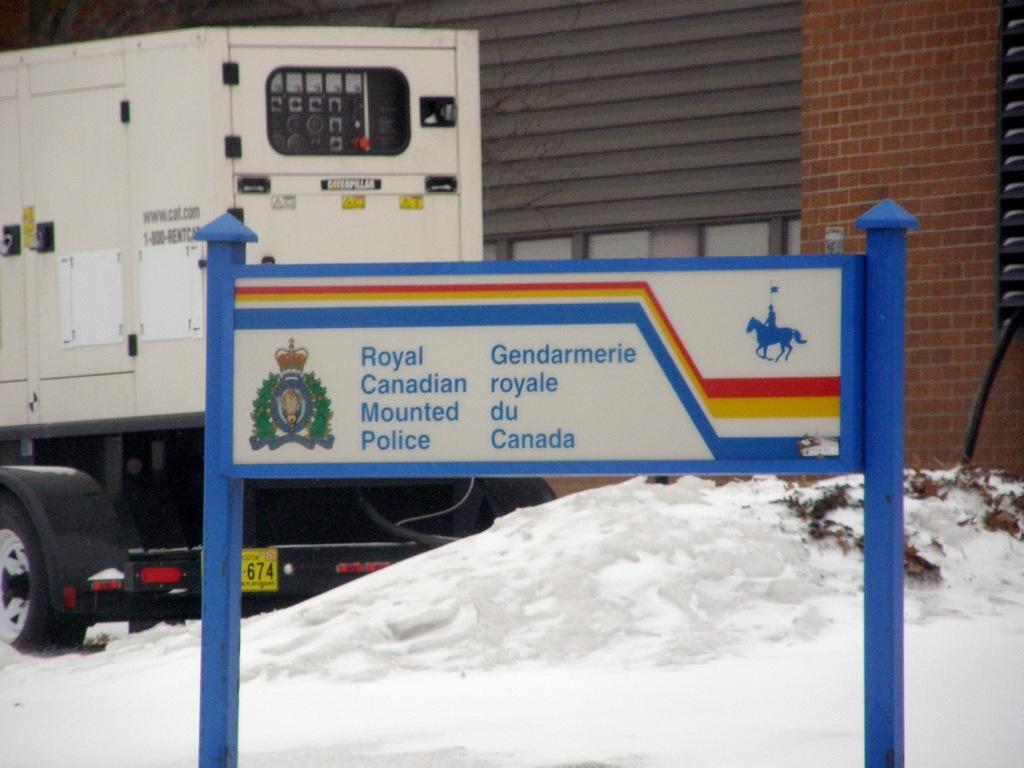What is the main object in the image with poles attached to it? There is a board with poles in the image. What can be seen written on the board? Something is written on the board. What is the weather condition in the background of the image? There is snow visible in the background. What type of vehicle is present in the image? There is a vehicle in the image. What is the material of the wall of the building in the image? There is a building with a brick wall in the image. What type of thread is being used to create the smoke in the image? There is no thread or smoke present in the image. How does the burn on the vehicle affect its functionality in the image? There is no burn or indication of a vehicle's functionality in the image. 